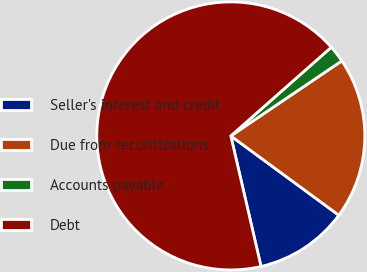Convert chart to OTSL. <chart><loc_0><loc_0><loc_500><loc_500><pie_chart><fcel>Seller's interest and credit<fcel>Due from securitizations<fcel>Accounts payable<fcel>Debt<nl><fcel>11.3%<fcel>19.54%<fcel>2.05%<fcel>67.11%<nl></chart> 